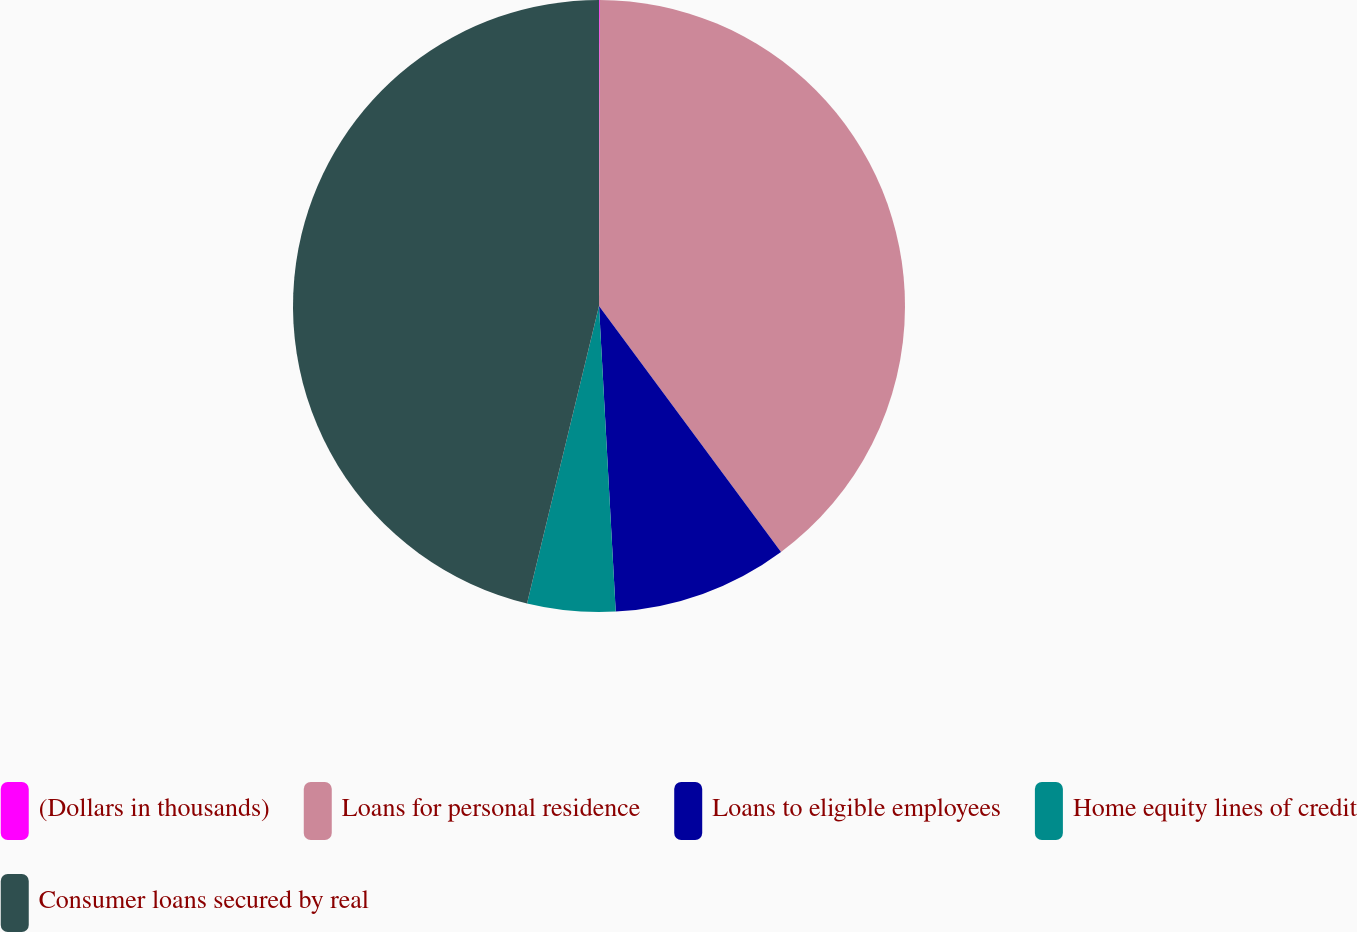Convert chart. <chart><loc_0><loc_0><loc_500><loc_500><pie_chart><fcel>(Dollars in thousands)<fcel>Loans for personal residence<fcel>Loans to eligible employees<fcel>Home equity lines of credit<fcel>Consumer loans secured by real<nl><fcel>0.04%<fcel>39.82%<fcel>9.27%<fcel>4.65%<fcel>46.22%<nl></chart> 